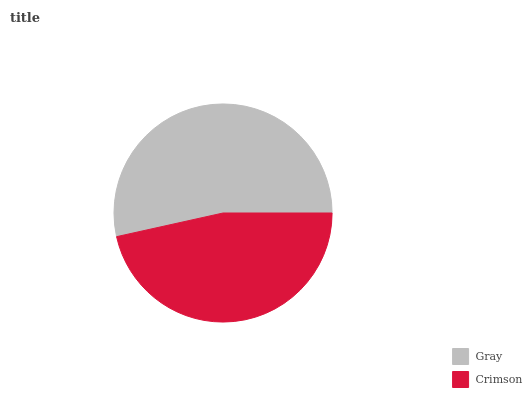Is Crimson the minimum?
Answer yes or no. Yes. Is Gray the maximum?
Answer yes or no. Yes. Is Crimson the maximum?
Answer yes or no. No. Is Gray greater than Crimson?
Answer yes or no. Yes. Is Crimson less than Gray?
Answer yes or no. Yes. Is Crimson greater than Gray?
Answer yes or no. No. Is Gray less than Crimson?
Answer yes or no. No. Is Gray the high median?
Answer yes or no. Yes. Is Crimson the low median?
Answer yes or no. Yes. Is Crimson the high median?
Answer yes or no. No. Is Gray the low median?
Answer yes or no. No. 